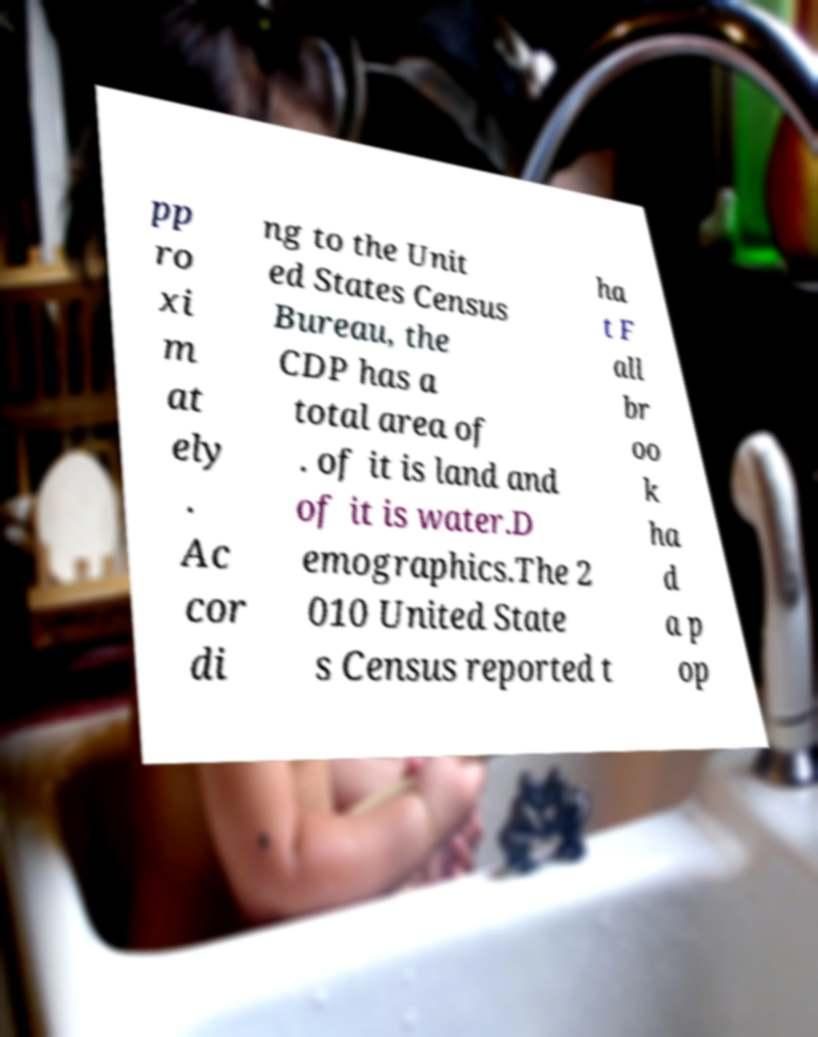Could you extract and type out the text from this image? pp ro xi m at ely . Ac cor di ng to the Unit ed States Census Bureau, the CDP has a total area of . of it is land and of it is water.D emographics.The 2 010 United State s Census reported t ha t F all br oo k ha d a p op 